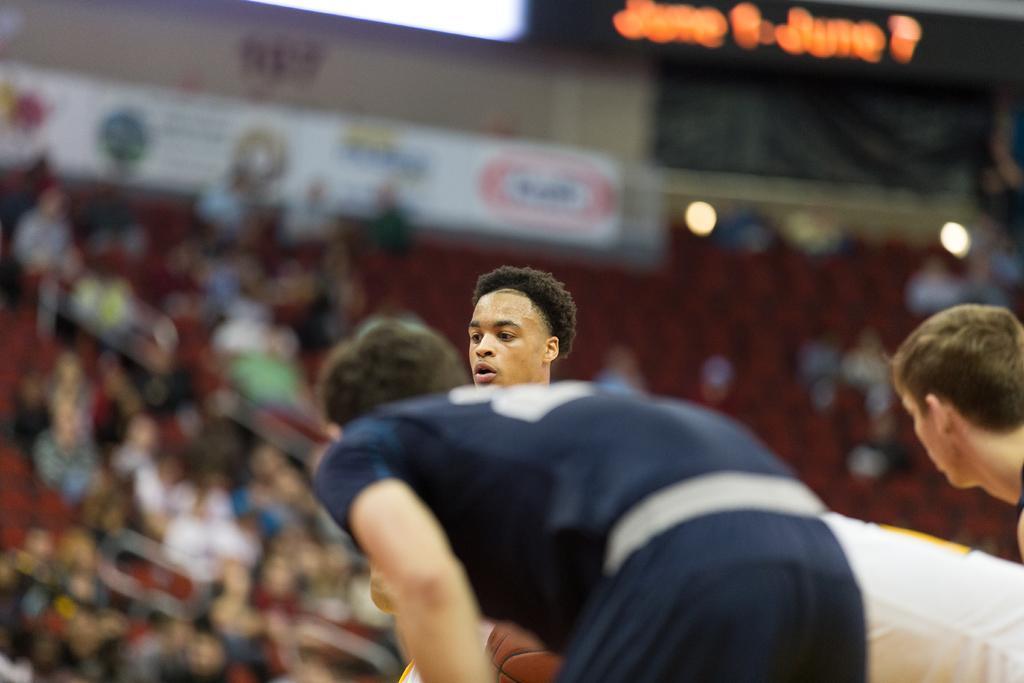Could you give a brief overview of what you see in this image? There are three persons. There is a blur background and we can see crowd. There are lights, and a hoarding. 